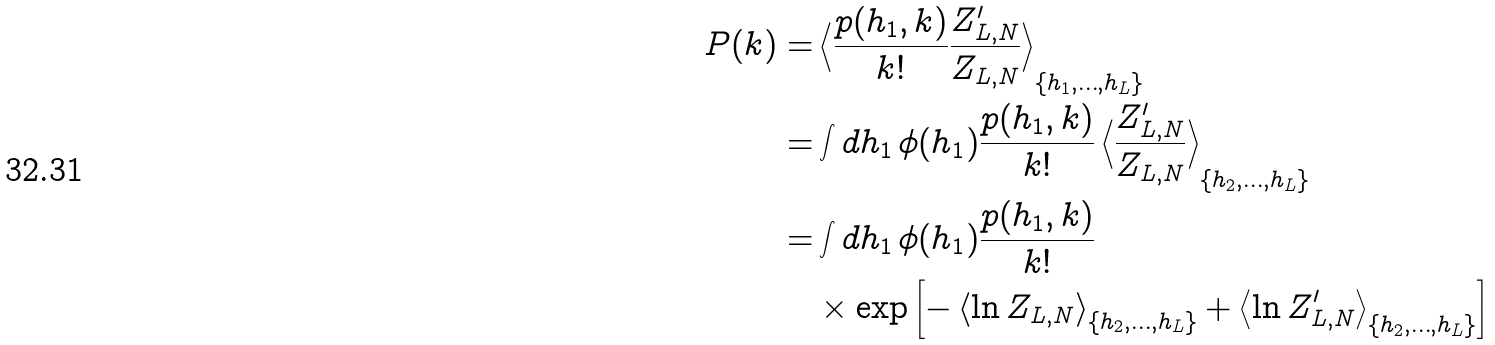Convert formula to latex. <formula><loc_0><loc_0><loc_500><loc_500>P ( k ) = & \left \langle \frac { p ( h _ { 1 } , k ) } { k ! } \frac { Z _ { L , N } ^ { \prime } } { Z _ { L , N } } \right \rangle _ { \{ h _ { 1 } , \dots , h _ { L } \} } \\ = & \int d h _ { 1 } \, \phi ( h _ { 1 } ) \frac { p ( h _ { 1 } , k ) } { k ! } \left \langle \frac { Z _ { L , N } ^ { \prime } } { Z _ { L , N } } \right \rangle _ { \{ h _ { 2 } , \dots , h _ { L } \} } \\ = & \int d h _ { 1 } \, \phi ( h _ { 1 } ) \frac { p ( h _ { 1 } , k ) } { k ! } \\ & \times \exp \left [ - \left \langle \ln Z _ { L , N } \right \rangle _ { \{ h _ { 2 } , \dots , h _ { L } \} } + \left \langle \ln Z _ { L , N } ^ { \prime } \right \rangle _ { \{ h _ { 2 } , \dots , h _ { L } \} } \right ]</formula> 